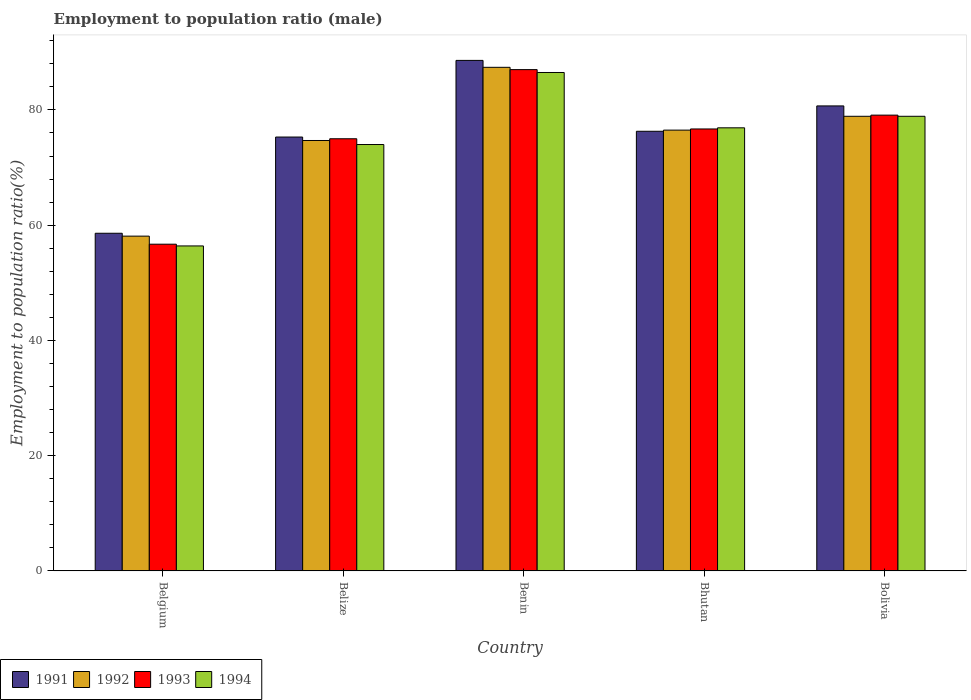How many different coloured bars are there?
Keep it short and to the point. 4. How many groups of bars are there?
Offer a very short reply. 5. How many bars are there on the 2nd tick from the left?
Ensure brevity in your answer.  4. How many bars are there on the 3rd tick from the right?
Your answer should be compact. 4. What is the label of the 1st group of bars from the left?
Provide a succinct answer. Belgium. In how many cases, is the number of bars for a given country not equal to the number of legend labels?
Give a very brief answer. 0. What is the employment to population ratio in 1994 in Bolivia?
Offer a terse response. 78.9. Across all countries, what is the maximum employment to population ratio in 1992?
Keep it short and to the point. 87.4. Across all countries, what is the minimum employment to population ratio in 1994?
Offer a very short reply. 56.4. In which country was the employment to population ratio in 1993 maximum?
Make the answer very short. Benin. In which country was the employment to population ratio in 1991 minimum?
Your response must be concise. Belgium. What is the total employment to population ratio in 1992 in the graph?
Provide a succinct answer. 375.6. What is the difference between the employment to population ratio in 1993 in Belize and that in Bhutan?
Provide a short and direct response. -1.7. What is the average employment to population ratio in 1991 per country?
Provide a succinct answer. 75.9. What is the difference between the employment to population ratio of/in 1993 and employment to population ratio of/in 1994 in Benin?
Give a very brief answer. 0.5. In how many countries, is the employment to population ratio in 1993 greater than 56 %?
Make the answer very short. 5. What is the ratio of the employment to population ratio in 1991 in Belgium to that in Belize?
Your answer should be very brief. 0.78. What is the difference between the highest and the second highest employment to population ratio in 1991?
Keep it short and to the point. 7.9. What is the difference between the highest and the lowest employment to population ratio in 1991?
Offer a very short reply. 30. Is it the case that in every country, the sum of the employment to population ratio in 1993 and employment to population ratio in 1994 is greater than the sum of employment to population ratio in 1992 and employment to population ratio in 1991?
Your response must be concise. No. What does the 2nd bar from the left in Bolivia represents?
Ensure brevity in your answer.  1992. Is it the case that in every country, the sum of the employment to population ratio in 1991 and employment to population ratio in 1992 is greater than the employment to population ratio in 1994?
Provide a short and direct response. Yes. How many bars are there?
Your response must be concise. 20. Does the graph contain any zero values?
Offer a terse response. No. Does the graph contain grids?
Offer a terse response. No. Where does the legend appear in the graph?
Offer a terse response. Bottom left. How are the legend labels stacked?
Provide a succinct answer. Horizontal. What is the title of the graph?
Keep it short and to the point. Employment to population ratio (male). What is the label or title of the X-axis?
Your response must be concise. Country. What is the label or title of the Y-axis?
Your answer should be compact. Employment to population ratio(%). What is the Employment to population ratio(%) in 1991 in Belgium?
Keep it short and to the point. 58.6. What is the Employment to population ratio(%) in 1992 in Belgium?
Your answer should be very brief. 58.1. What is the Employment to population ratio(%) in 1993 in Belgium?
Your response must be concise. 56.7. What is the Employment to population ratio(%) in 1994 in Belgium?
Make the answer very short. 56.4. What is the Employment to population ratio(%) in 1991 in Belize?
Offer a very short reply. 75.3. What is the Employment to population ratio(%) in 1992 in Belize?
Your answer should be very brief. 74.7. What is the Employment to population ratio(%) in 1993 in Belize?
Your answer should be compact. 75. What is the Employment to population ratio(%) of 1991 in Benin?
Provide a short and direct response. 88.6. What is the Employment to population ratio(%) in 1992 in Benin?
Offer a very short reply. 87.4. What is the Employment to population ratio(%) in 1994 in Benin?
Provide a succinct answer. 86.5. What is the Employment to population ratio(%) of 1991 in Bhutan?
Your answer should be compact. 76.3. What is the Employment to population ratio(%) of 1992 in Bhutan?
Provide a succinct answer. 76.5. What is the Employment to population ratio(%) in 1993 in Bhutan?
Your answer should be very brief. 76.7. What is the Employment to population ratio(%) in 1994 in Bhutan?
Provide a succinct answer. 76.9. What is the Employment to population ratio(%) in 1991 in Bolivia?
Ensure brevity in your answer.  80.7. What is the Employment to population ratio(%) of 1992 in Bolivia?
Ensure brevity in your answer.  78.9. What is the Employment to population ratio(%) in 1993 in Bolivia?
Provide a short and direct response. 79.1. What is the Employment to population ratio(%) in 1994 in Bolivia?
Your answer should be very brief. 78.9. Across all countries, what is the maximum Employment to population ratio(%) of 1991?
Your answer should be compact. 88.6. Across all countries, what is the maximum Employment to population ratio(%) of 1992?
Offer a terse response. 87.4. Across all countries, what is the maximum Employment to population ratio(%) of 1994?
Offer a terse response. 86.5. Across all countries, what is the minimum Employment to population ratio(%) in 1991?
Your answer should be compact. 58.6. Across all countries, what is the minimum Employment to population ratio(%) in 1992?
Your response must be concise. 58.1. Across all countries, what is the minimum Employment to population ratio(%) in 1993?
Make the answer very short. 56.7. Across all countries, what is the minimum Employment to population ratio(%) of 1994?
Make the answer very short. 56.4. What is the total Employment to population ratio(%) in 1991 in the graph?
Your response must be concise. 379.5. What is the total Employment to population ratio(%) of 1992 in the graph?
Give a very brief answer. 375.6. What is the total Employment to population ratio(%) of 1993 in the graph?
Give a very brief answer. 374.5. What is the total Employment to population ratio(%) in 1994 in the graph?
Your answer should be compact. 372.7. What is the difference between the Employment to population ratio(%) in 1991 in Belgium and that in Belize?
Provide a succinct answer. -16.7. What is the difference between the Employment to population ratio(%) in 1992 in Belgium and that in Belize?
Provide a succinct answer. -16.6. What is the difference between the Employment to population ratio(%) in 1993 in Belgium and that in Belize?
Give a very brief answer. -18.3. What is the difference between the Employment to population ratio(%) of 1994 in Belgium and that in Belize?
Offer a terse response. -17.6. What is the difference between the Employment to population ratio(%) in 1991 in Belgium and that in Benin?
Your response must be concise. -30. What is the difference between the Employment to population ratio(%) in 1992 in Belgium and that in Benin?
Your answer should be compact. -29.3. What is the difference between the Employment to population ratio(%) in 1993 in Belgium and that in Benin?
Ensure brevity in your answer.  -30.3. What is the difference between the Employment to population ratio(%) of 1994 in Belgium and that in Benin?
Provide a succinct answer. -30.1. What is the difference between the Employment to population ratio(%) of 1991 in Belgium and that in Bhutan?
Ensure brevity in your answer.  -17.7. What is the difference between the Employment to population ratio(%) of 1992 in Belgium and that in Bhutan?
Ensure brevity in your answer.  -18.4. What is the difference between the Employment to population ratio(%) of 1994 in Belgium and that in Bhutan?
Your response must be concise. -20.5. What is the difference between the Employment to population ratio(%) in 1991 in Belgium and that in Bolivia?
Your answer should be very brief. -22.1. What is the difference between the Employment to population ratio(%) in 1992 in Belgium and that in Bolivia?
Make the answer very short. -20.8. What is the difference between the Employment to population ratio(%) in 1993 in Belgium and that in Bolivia?
Make the answer very short. -22.4. What is the difference between the Employment to population ratio(%) in 1994 in Belgium and that in Bolivia?
Give a very brief answer. -22.5. What is the difference between the Employment to population ratio(%) in 1991 in Belize and that in Benin?
Keep it short and to the point. -13.3. What is the difference between the Employment to population ratio(%) in 1993 in Belize and that in Benin?
Offer a very short reply. -12. What is the difference between the Employment to population ratio(%) in 1991 in Belize and that in Bhutan?
Give a very brief answer. -1. What is the difference between the Employment to population ratio(%) in 1992 in Belize and that in Bhutan?
Keep it short and to the point. -1.8. What is the difference between the Employment to population ratio(%) in 1993 in Belize and that in Bhutan?
Provide a succinct answer. -1.7. What is the difference between the Employment to population ratio(%) of 1994 in Belize and that in Bhutan?
Your answer should be very brief. -2.9. What is the difference between the Employment to population ratio(%) of 1993 in Belize and that in Bolivia?
Your answer should be very brief. -4.1. What is the difference between the Employment to population ratio(%) of 1994 in Belize and that in Bolivia?
Your response must be concise. -4.9. What is the difference between the Employment to population ratio(%) in 1992 in Benin and that in Bhutan?
Offer a very short reply. 10.9. What is the difference between the Employment to population ratio(%) in 1993 in Benin and that in Bhutan?
Keep it short and to the point. 10.3. What is the difference between the Employment to population ratio(%) in 1994 in Benin and that in Bhutan?
Your answer should be compact. 9.6. What is the difference between the Employment to population ratio(%) in 1991 in Benin and that in Bolivia?
Your answer should be compact. 7.9. What is the difference between the Employment to population ratio(%) of 1994 in Benin and that in Bolivia?
Ensure brevity in your answer.  7.6. What is the difference between the Employment to population ratio(%) in 1993 in Bhutan and that in Bolivia?
Offer a very short reply. -2.4. What is the difference between the Employment to population ratio(%) in 1994 in Bhutan and that in Bolivia?
Offer a terse response. -2. What is the difference between the Employment to population ratio(%) of 1991 in Belgium and the Employment to population ratio(%) of 1992 in Belize?
Your answer should be very brief. -16.1. What is the difference between the Employment to population ratio(%) in 1991 in Belgium and the Employment to population ratio(%) in 1993 in Belize?
Offer a terse response. -16.4. What is the difference between the Employment to population ratio(%) in 1991 in Belgium and the Employment to population ratio(%) in 1994 in Belize?
Provide a succinct answer. -15.4. What is the difference between the Employment to population ratio(%) of 1992 in Belgium and the Employment to population ratio(%) of 1993 in Belize?
Keep it short and to the point. -16.9. What is the difference between the Employment to population ratio(%) of 1992 in Belgium and the Employment to population ratio(%) of 1994 in Belize?
Make the answer very short. -15.9. What is the difference between the Employment to population ratio(%) of 1993 in Belgium and the Employment to population ratio(%) of 1994 in Belize?
Provide a succinct answer. -17.3. What is the difference between the Employment to population ratio(%) of 1991 in Belgium and the Employment to population ratio(%) of 1992 in Benin?
Your response must be concise. -28.8. What is the difference between the Employment to population ratio(%) in 1991 in Belgium and the Employment to population ratio(%) in 1993 in Benin?
Make the answer very short. -28.4. What is the difference between the Employment to population ratio(%) in 1991 in Belgium and the Employment to population ratio(%) in 1994 in Benin?
Your response must be concise. -27.9. What is the difference between the Employment to population ratio(%) of 1992 in Belgium and the Employment to population ratio(%) of 1993 in Benin?
Offer a terse response. -28.9. What is the difference between the Employment to population ratio(%) of 1992 in Belgium and the Employment to population ratio(%) of 1994 in Benin?
Provide a short and direct response. -28.4. What is the difference between the Employment to population ratio(%) in 1993 in Belgium and the Employment to population ratio(%) in 1994 in Benin?
Provide a short and direct response. -29.8. What is the difference between the Employment to population ratio(%) in 1991 in Belgium and the Employment to population ratio(%) in 1992 in Bhutan?
Your response must be concise. -17.9. What is the difference between the Employment to population ratio(%) in 1991 in Belgium and the Employment to population ratio(%) in 1993 in Bhutan?
Make the answer very short. -18.1. What is the difference between the Employment to population ratio(%) in 1991 in Belgium and the Employment to population ratio(%) in 1994 in Bhutan?
Offer a terse response. -18.3. What is the difference between the Employment to population ratio(%) in 1992 in Belgium and the Employment to population ratio(%) in 1993 in Bhutan?
Make the answer very short. -18.6. What is the difference between the Employment to population ratio(%) of 1992 in Belgium and the Employment to population ratio(%) of 1994 in Bhutan?
Your answer should be compact. -18.8. What is the difference between the Employment to population ratio(%) in 1993 in Belgium and the Employment to population ratio(%) in 1994 in Bhutan?
Your response must be concise. -20.2. What is the difference between the Employment to population ratio(%) of 1991 in Belgium and the Employment to population ratio(%) of 1992 in Bolivia?
Ensure brevity in your answer.  -20.3. What is the difference between the Employment to population ratio(%) in 1991 in Belgium and the Employment to population ratio(%) in 1993 in Bolivia?
Provide a short and direct response. -20.5. What is the difference between the Employment to population ratio(%) in 1991 in Belgium and the Employment to population ratio(%) in 1994 in Bolivia?
Keep it short and to the point. -20.3. What is the difference between the Employment to population ratio(%) of 1992 in Belgium and the Employment to population ratio(%) of 1994 in Bolivia?
Make the answer very short. -20.8. What is the difference between the Employment to population ratio(%) in 1993 in Belgium and the Employment to population ratio(%) in 1994 in Bolivia?
Your response must be concise. -22.2. What is the difference between the Employment to population ratio(%) in 1991 in Belize and the Employment to population ratio(%) in 1992 in Benin?
Ensure brevity in your answer.  -12.1. What is the difference between the Employment to population ratio(%) in 1991 in Belize and the Employment to population ratio(%) in 1994 in Benin?
Keep it short and to the point. -11.2. What is the difference between the Employment to population ratio(%) in 1991 in Belize and the Employment to population ratio(%) in 1992 in Bhutan?
Provide a succinct answer. -1.2. What is the difference between the Employment to population ratio(%) in 1991 in Belize and the Employment to population ratio(%) in 1993 in Bhutan?
Provide a succinct answer. -1.4. What is the difference between the Employment to population ratio(%) of 1992 in Belize and the Employment to population ratio(%) of 1994 in Bhutan?
Give a very brief answer. -2.2. What is the difference between the Employment to population ratio(%) of 1993 in Belize and the Employment to population ratio(%) of 1994 in Bolivia?
Provide a short and direct response. -3.9. What is the difference between the Employment to population ratio(%) of 1991 in Benin and the Employment to population ratio(%) of 1993 in Bhutan?
Your answer should be compact. 11.9. What is the difference between the Employment to population ratio(%) of 1991 in Benin and the Employment to population ratio(%) of 1994 in Bhutan?
Offer a very short reply. 11.7. What is the difference between the Employment to population ratio(%) in 1992 in Benin and the Employment to population ratio(%) in 1994 in Bhutan?
Ensure brevity in your answer.  10.5. What is the difference between the Employment to population ratio(%) of 1993 in Benin and the Employment to population ratio(%) of 1994 in Bhutan?
Your answer should be compact. 10.1. What is the difference between the Employment to population ratio(%) of 1991 in Benin and the Employment to population ratio(%) of 1992 in Bolivia?
Your response must be concise. 9.7. What is the difference between the Employment to population ratio(%) in 1991 in Benin and the Employment to population ratio(%) in 1993 in Bolivia?
Make the answer very short. 9.5. What is the difference between the Employment to population ratio(%) in 1991 in Benin and the Employment to population ratio(%) in 1994 in Bolivia?
Offer a terse response. 9.7. What is the difference between the Employment to population ratio(%) in 1992 in Benin and the Employment to population ratio(%) in 1993 in Bolivia?
Keep it short and to the point. 8.3. What is the difference between the Employment to population ratio(%) in 1991 in Bhutan and the Employment to population ratio(%) in 1992 in Bolivia?
Provide a short and direct response. -2.6. What is the difference between the Employment to population ratio(%) in 1992 in Bhutan and the Employment to population ratio(%) in 1993 in Bolivia?
Keep it short and to the point. -2.6. What is the difference between the Employment to population ratio(%) in 1992 in Bhutan and the Employment to population ratio(%) in 1994 in Bolivia?
Ensure brevity in your answer.  -2.4. What is the difference between the Employment to population ratio(%) of 1993 in Bhutan and the Employment to population ratio(%) of 1994 in Bolivia?
Provide a short and direct response. -2.2. What is the average Employment to population ratio(%) in 1991 per country?
Keep it short and to the point. 75.9. What is the average Employment to population ratio(%) in 1992 per country?
Give a very brief answer. 75.12. What is the average Employment to population ratio(%) of 1993 per country?
Provide a short and direct response. 74.9. What is the average Employment to population ratio(%) in 1994 per country?
Offer a terse response. 74.54. What is the difference between the Employment to population ratio(%) in 1991 and Employment to population ratio(%) in 1992 in Belgium?
Provide a succinct answer. 0.5. What is the difference between the Employment to population ratio(%) in 1991 and Employment to population ratio(%) in 1994 in Belgium?
Keep it short and to the point. 2.2. What is the difference between the Employment to population ratio(%) in 1992 and Employment to population ratio(%) in 1993 in Belgium?
Give a very brief answer. 1.4. What is the difference between the Employment to population ratio(%) of 1993 and Employment to population ratio(%) of 1994 in Belgium?
Your response must be concise. 0.3. What is the difference between the Employment to population ratio(%) in 1992 and Employment to population ratio(%) in 1993 in Belize?
Give a very brief answer. -0.3. What is the difference between the Employment to population ratio(%) of 1992 and Employment to population ratio(%) of 1994 in Belize?
Your answer should be very brief. 0.7. What is the difference between the Employment to population ratio(%) of 1991 and Employment to population ratio(%) of 1992 in Benin?
Ensure brevity in your answer.  1.2. What is the difference between the Employment to population ratio(%) in 1991 and Employment to population ratio(%) in 1993 in Benin?
Offer a very short reply. 1.6. What is the difference between the Employment to population ratio(%) of 1992 and Employment to population ratio(%) of 1993 in Benin?
Your answer should be very brief. 0.4. What is the difference between the Employment to population ratio(%) in 1991 and Employment to population ratio(%) in 1993 in Bhutan?
Your response must be concise. -0.4. What is the difference between the Employment to population ratio(%) in 1992 and Employment to population ratio(%) in 1993 in Bhutan?
Ensure brevity in your answer.  -0.2. What is the difference between the Employment to population ratio(%) of 1993 and Employment to population ratio(%) of 1994 in Bhutan?
Ensure brevity in your answer.  -0.2. What is the difference between the Employment to population ratio(%) of 1991 and Employment to population ratio(%) of 1992 in Bolivia?
Your answer should be compact. 1.8. What is the difference between the Employment to population ratio(%) in 1991 and Employment to population ratio(%) in 1994 in Bolivia?
Your answer should be compact. 1.8. What is the difference between the Employment to population ratio(%) of 1992 and Employment to population ratio(%) of 1993 in Bolivia?
Provide a succinct answer. -0.2. What is the ratio of the Employment to population ratio(%) of 1991 in Belgium to that in Belize?
Offer a terse response. 0.78. What is the ratio of the Employment to population ratio(%) in 1993 in Belgium to that in Belize?
Provide a succinct answer. 0.76. What is the ratio of the Employment to population ratio(%) of 1994 in Belgium to that in Belize?
Give a very brief answer. 0.76. What is the ratio of the Employment to population ratio(%) of 1991 in Belgium to that in Benin?
Your answer should be compact. 0.66. What is the ratio of the Employment to population ratio(%) in 1992 in Belgium to that in Benin?
Give a very brief answer. 0.66. What is the ratio of the Employment to population ratio(%) in 1993 in Belgium to that in Benin?
Your response must be concise. 0.65. What is the ratio of the Employment to population ratio(%) in 1994 in Belgium to that in Benin?
Offer a terse response. 0.65. What is the ratio of the Employment to population ratio(%) of 1991 in Belgium to that in Bhutan?
Your answer should be compact. 0.77. What is the ratio of the Employment to population ratio(%) in 1992 in Belgium to that in Bhutan?
Make the answer very short. 0.76. What is the ratio of the Employment to population ratio(%) of 1993 in Belgium to that in Bhutan?
Provide a succinct answer. 0.74. What is the ratio of the Employment to population ratio(%) in 1994 in Belgium to that in Bhutan?
Offer a terse response. 0.73. What is the ratio of the Employment to population ratio(%) of 1991 in Belgium to that in Bolivia?
Provide a succinct answer. 0.73. What is the ratio of the Employment to population ratio(%) of 1992 in Belgium to that in Bolivia?
Your answer should be very brief. 0.74. What is the ratio of the Employment to population ratio(%) of 1993 in Belgium to that in Bolivia?
Give a very brief answer. 0.72. What is the ratio of the Employment to population ratio(%) in 1994 in Belgium to that in Bolivia?
Make the answer very short. 0.71. What is the ratio of the Employment to population ratio(%) in 1991 in Belize to that in Benin?
Your response must be concise. 0.85. What is the ratio of the Employment to population ratio(%) in 1992 in Belize to that in Benin?
Ensure brevity in your answer.  0.85. What is the ratio of the Employment to population ratio(%) of 1993 in Belize to that in Benin?
Provide a succinct answer. 0.86. What is the ratio of the Employment to population ratio(%) in 1994 in Belize to that in Benin?
Offer a terse response. 0.86. What is the ratio of the Employment to population ratio(%) in 1991 in Belize to that in Bhutan?
Your answer should be compact. 0.99. What is the ratio of the Employment to population ratio(%) in 1992 in Belize to that in Bhutan?
Your answer should be very brief. 0.98. What is the ratio of the Employment to population ratio(%) of 1993 in Belize to that in Bhutan?
Offer a terse response. 0.98. What is the ratio of the Employment to population ratio(%) of 1994 in Belize to that in Bhutan?
Make the answer very short. 0.96. What is the ratio of the Employment to population ratio(%) in 1991 in Belize to that in Bolivia?
Provide a succinct answer. 0.93. What is the ratio of the Employment to population ratio(%) in 1992 in Belize to that in Bolivia?
Provide a succinct answer. 0.95. What is the ratio of the Employment to population ratio(%) of 1993 in Belize to that in Bolivia?
Provide a succinct answer. 0.95. What is the ratio of the Employment to population ratio(%) in 1994 in Belize to that in Bolivia?
Offer a very short reply. 0.94. What is the ratio of the Employment to population ratio(%) in 1991 in Benin to that in Bhutan?
Offer a very short reply. 1.16. What is the ratio of the Employment to population ratio(%) in 1992 in Benin to that in Bhutan?
Make the answer very short. 1.14. What is the ratio of the Employment to population ratio(%) in 1993 in Benin to that in Bhutan?
Provide a succinct answer. 1.13. What is the ratio of the Employment to population ratio(%) in 1994 in Benin to that in Bhutan?
Keep it short and to the point. 1.12. What is the ratio of the Employment to population ratio(%) of 1991 in Benin to that in Bolivia?
Offer a terse response. 1.1. What is the ratio of the Employment to population ratio(%) in 1992 in Benin to that in Bolivia?
Provide a succinct answer. 1.11. What is the ratio of the Employment to population ratio(%) of 1993 in Benin to that in Bolivia?
Offer a very short reply. 1.1. What is the ratio of the Employment to population ratio(%) of 1994 in Benin to that in Bolivia?
Your answer should be compact. 1.1. What is the ratio of the Employment to population ratio(%) in 1991 in Bhutan to that in Bolivia?
Make the answer very short. 0.95. What is the ratio of the Employment to population ratio(%) in 1992 in Bhutan to that in Bolivia?
Your response must be concise. 0.97. What is the ratio of the Employment to population ratio(%) of 1993 in Bhutan to that in Bolivia?
Your answer should be compact. 0.97. What is the ratio of the Employment to population ratio(%) of 1994 in Bhutan to that in Bolivia?
Provide a succinct answer. 0.97. What is the difference between the highest and the second highest Employment to population ratio(%) in 1993?
Ensure brevity in your answer.  7.9. What is the difference between the highest and the lowest Employment to population ratio(%) in 1992?
Provide a succinct answer. 29.3. What is the difference between the highest and the lowest Employment to population ratio(%) of 1993?
Your response must be concise. 30.3. What is the difference between the highest and the lowest Employment to population ratio(%) of 1994?
Your response must be concise. 30.1. 